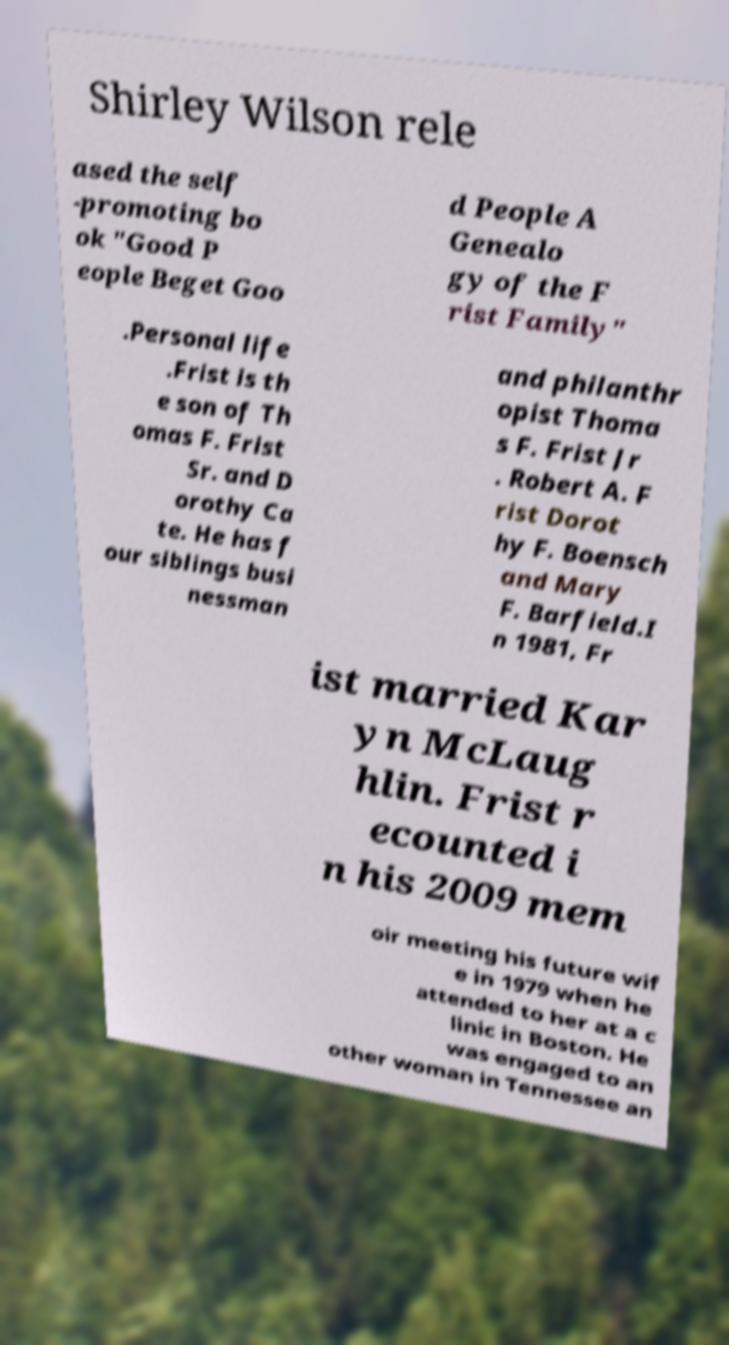Please read and relay the text visible in this image. What does it say? Shirley Wilson rele ased the self -promoting bo ok "Good P eople Beget Goo d People A Genealo gy of the F rist Family" .Personal life .Frist is th e son of Th omas F. Frist Sr. and D orothy Ca te. He has f our siblings busi nessman and philanthr opist Thoma s F. Frist Jr . Robert A. F rist Dorot hy F. Boensch and Mary F. Barfield.I n 1981, Fr ist married Kar yn McLaug hlin. Frist r ecounted i n his 2009 mem oir meeting his future wif e in 1979 when he attended to her at a c linic in Boston. He was engaged to an other woman in Tennessee an 